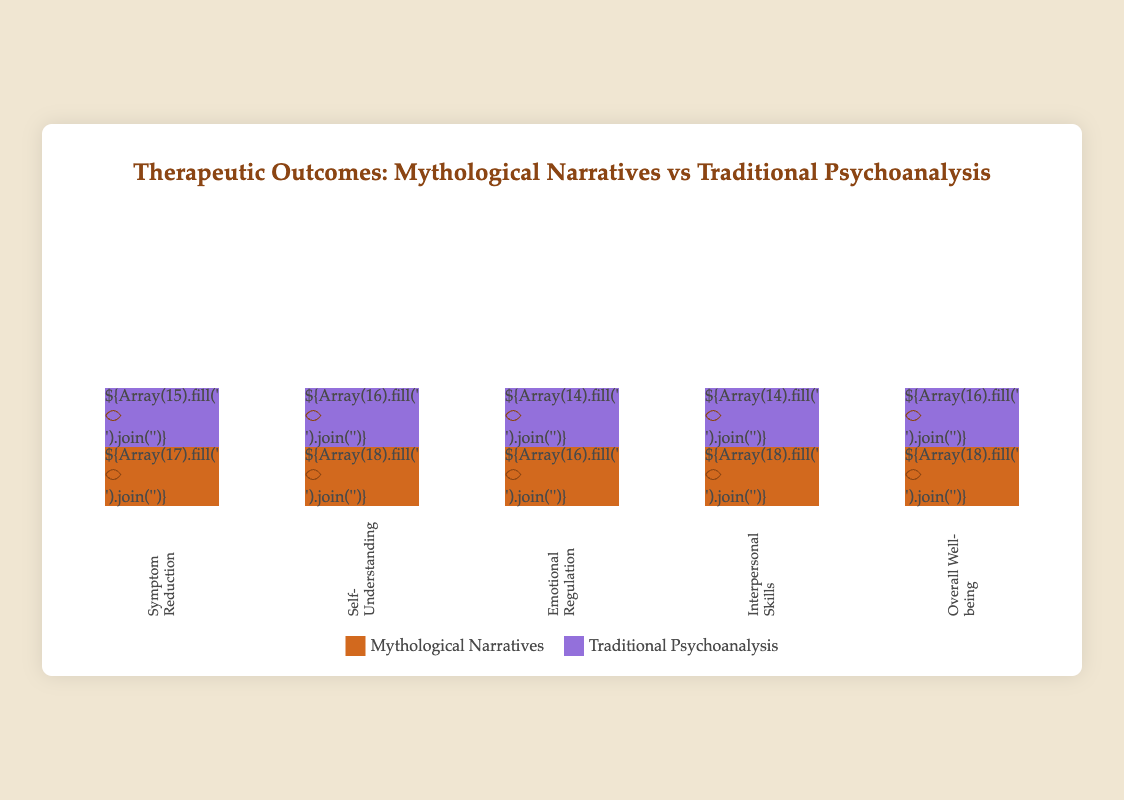What is the title of the figure? The title of the figure is displayed at the top of the chart in a prominent position and larger font size. It summarizes the main comparison made in the plot.
Answer: "Therapeutic Outcomes: Mythological Narratives vs Traditional Psychoanalysis" What categories are analyzed in this figure? The categories are depicted as vertical columns under each bar, aligning with different aspects of therapeutic outcomes. They are "Symptom Reduction", "Self-Understanding", "Emotional Regulation", "Interpersonal Skills", and "Overall Well-being".
Answer: "Symptom Reduction", "Self-Understanding", "Emotional Regulation", "Interpersonal Skills", "Overall Well-being" Which method shows higher outcomes in "Self-Understanding"? By visually comparing the heights of the bars for "Self-Understanding", you can see that the bar for "Mythological Narratives" has 18 icons while "Traditional Psychoanalysis" has 16 icons.
Answer: Mythological Narratives How many unit icons represent "Interpersonal Skills" for the "Traditional Psychoanalysis" method? The "Interpersonal Skills" category shows two different bar heights, with the one for "Traditional Psychoanalysis" having 14 person icons.
Answer: 14 On which category do the two methods show the greatest difference in outcomes? To find the greatest difference, compare the height of each pair of bars for all categories. "Interpersonal Skills" shows a difference of 4 icons (18 for Mythological Narratives and 14 for Traditional Psychoanalysis), which is the largest gap.
Answer: Interpersonal Skills How many more unit icons are used for "Emotional Regulation" in Mythological Narratives compared to Traditional Psychoanalysis? In "Emotional Regulation", count and compare the number of unit icons between the two methods: 16 for Mythological Narratives and 14 for Traditional Psychoanalysis, giving a difference of 2.
Answer: 2 What might indicate the overall superior method based on the isotype plot? By observing each category, Mythological Narratives consistently perform higher or equal compared to Traditional Psychoanalysis, which suggests it could be considered the overall superior method.
Answer: Mythological Narratives How do the methods compare in terms of "Overall Well-being"? For "Overall Well-being", Mythological Narratives use 18 icons, whereas Traditional Psychoanalysis uses 16 icons, making Mythological Narratives higher by 2 icons.
Answer: Mythological Narratives are better Which therapeutic method appears more effective in enhancing Interpersonal Skills? The bar for "Interpersonal Skills" under Mythological Narratives has 18 icons while Traditional Psychoanalysis has 14 icons, indicating that Mythological Narratives is more effective.
Answer: Mythological Narratives 